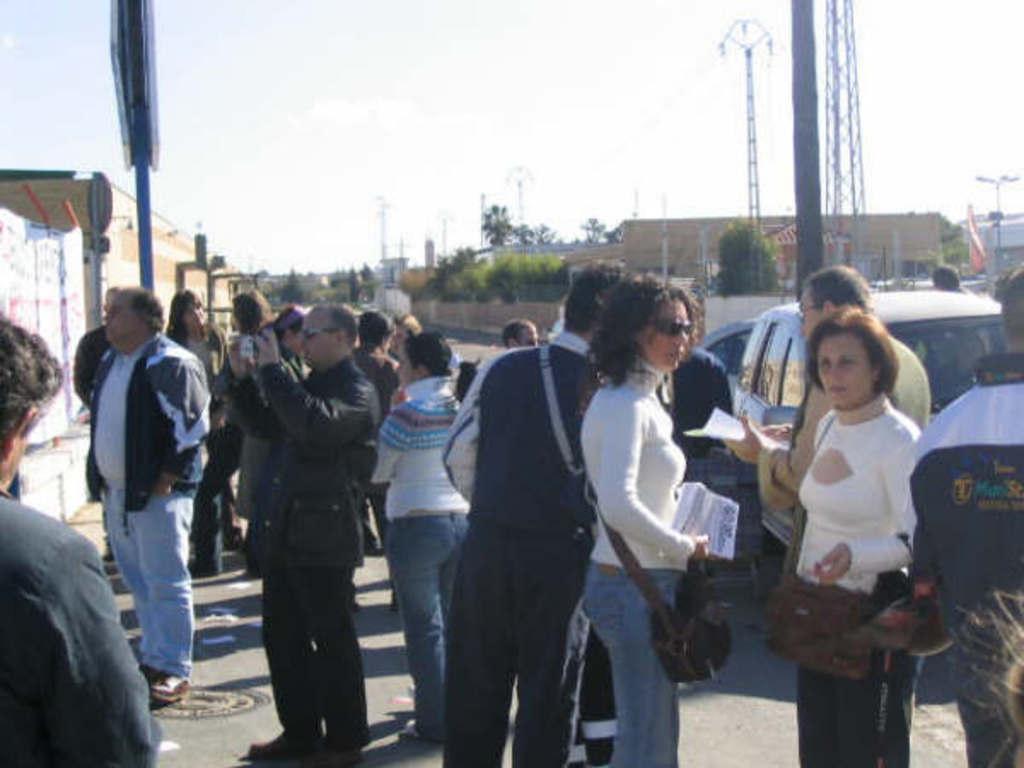Could you give a brief overview of what you see in this image? In this picture I can see a few people standing on the road. I can see a person holding the camera. I can see the vehicles on the right side. I can see the buildings. I can see the electric poles. I can see clouds in the sky. I can see trees. 